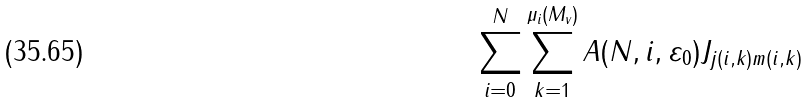<formula> <loc_0><loc_0><loc_500><loc_500>\sum _ { i = 0 } ^ { N } \sum _ { k = 1 } ^ { \mu _ { i } ( M _ { v } ) } A ( N , i , \varepsilon _ { 0 } ) J _ { j ( i , k ) m ( i , k ) }</formula> 